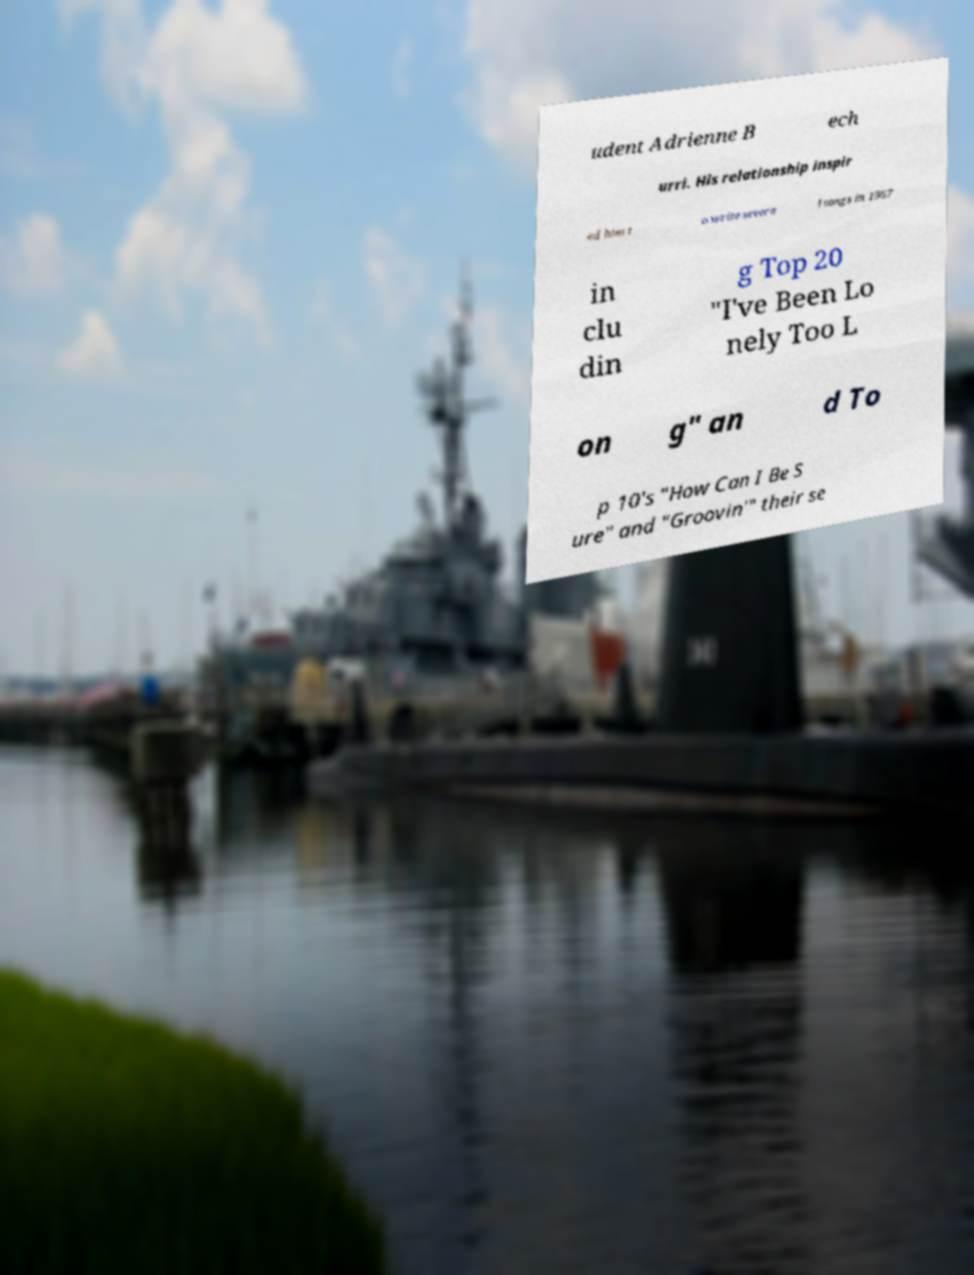What messages or text are displayed in this image? I need them in a readable, typed format. udent Adrienne B ech urri. His relationship inspir ed him t o write severa l songs in 1967 in clu din g Top 20 "I've Been Lo nely Too L on g" an d To p 10's "How Can I Be S ure" and "Groovin'" their se 